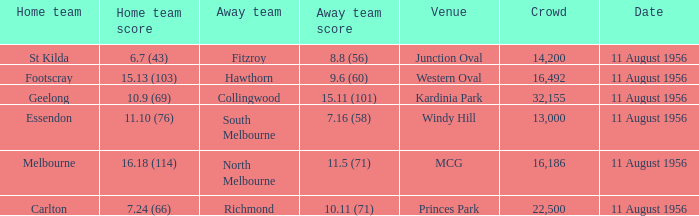Write the full table. {'header': ['Home team', 'Home team score', 'Away team', 'Away team score', 'Venue', 'Crowd', 'Date'], 'rows': [['St Kilda', '6.7 (43)', 'Fitzroy', '8.8 (56)', 'Junction Oval', '14,200', '11 August 1956'], ['Footscray', '15.13 (103)', 'Hawthorn', '9.6 (60)', 'Western Oval', '16,492', '11 August 1956'], ['Geelong', '10.9 (69)', 'Collingwood', '15.11 (101)', 'Kardinia Park', '32,155', '11 August 1956'], ['Essendon', '11.10 (76)', 'South Melbourne', '7.16 (58)', 'Windy Hill', '13,000', '11 August 1956'], ['Melbourne', '16.18 (114)', 'North Melbourne', '11.5 (71)', 'MCG', '16,186', '11 August 1956'], ['Carlton', '7.24 (66)', 'Richmond', '10.11 (71)', 'Princes Park', '22,500', '11 August 1956']]} What home team has a score of 16.18 (114)? Melbourne. 